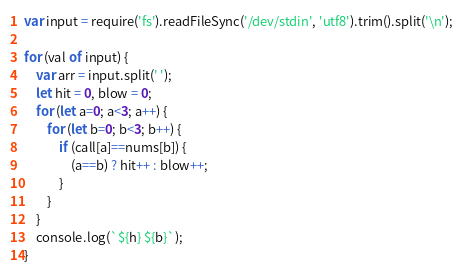Convert code to text. <code><loc_0><loc_0><loc_500><loc_500><_JavaScript_>var input = require('fs').readFileSync('/dev/stdin', 'utf8').trim().split('\n');

for (val of input) {
	var arr = input.split(' ');
	let hit = 0, blow = 0;
	for (let a=0; a<3; a++) {
		for (let b=0; b<3; b++) {
			if (call[a]==nums[b]) {
				(a==b) ? hit++ : blow++;
			}
		}
	}
	console.log(`${h} ${b}`);
}</code> 